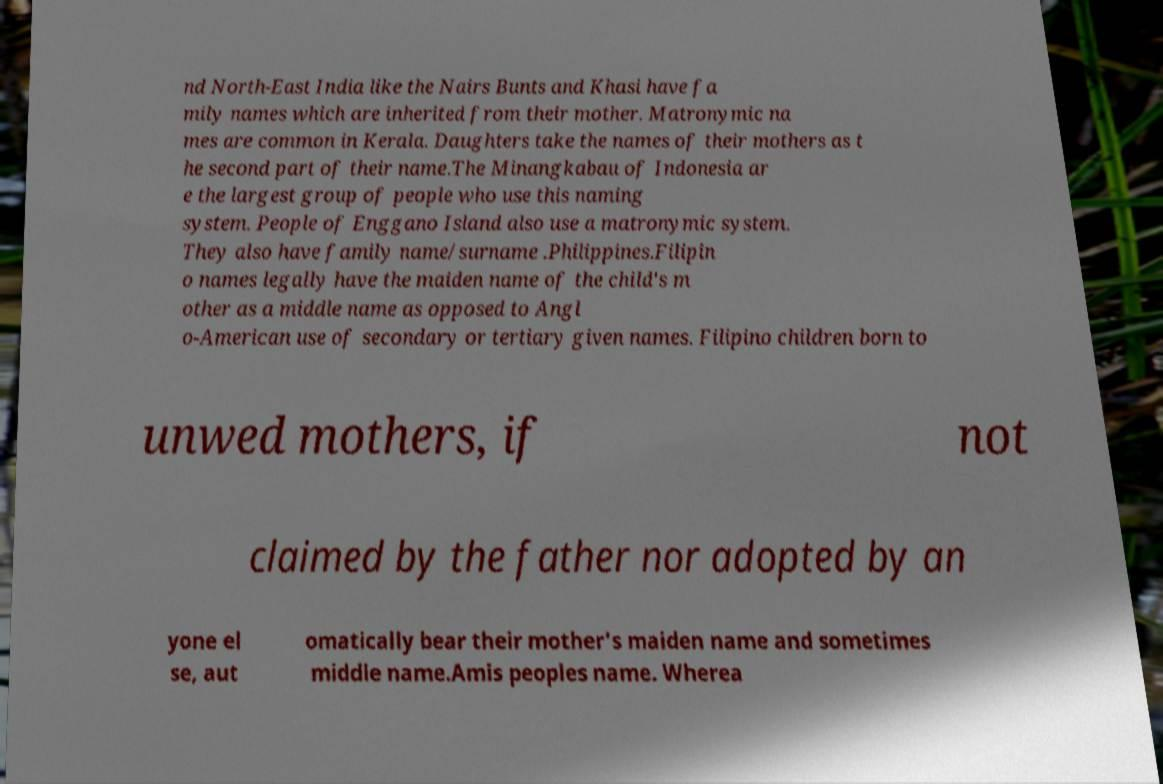Could you assist in decoding the text presented in this image and type it out clearly? nd North-East India like the Nairs Bunts and Khasi have fa mily names which are inherited from their mother. Matronymic na mes are common in Kerala. Daughters take the names of their mothers as t he second part of their name.The Minangkabau of Indonesia ar e the largest group of people who use this naming system. People of Enggano Island also use a matronymic system. They also have family name/surname .Philippines.Filipin o names legally have the maiden name of the child's m other as a middle name as opposed to Angl o-American use of secondary or tertiary given names. Filipino children born to unwed mothers, if not claimed by the father nor adopted by an yone el se, aut omatically bear their mother's maiden name and sometimes middle name.Amis peoples name. Wherea 